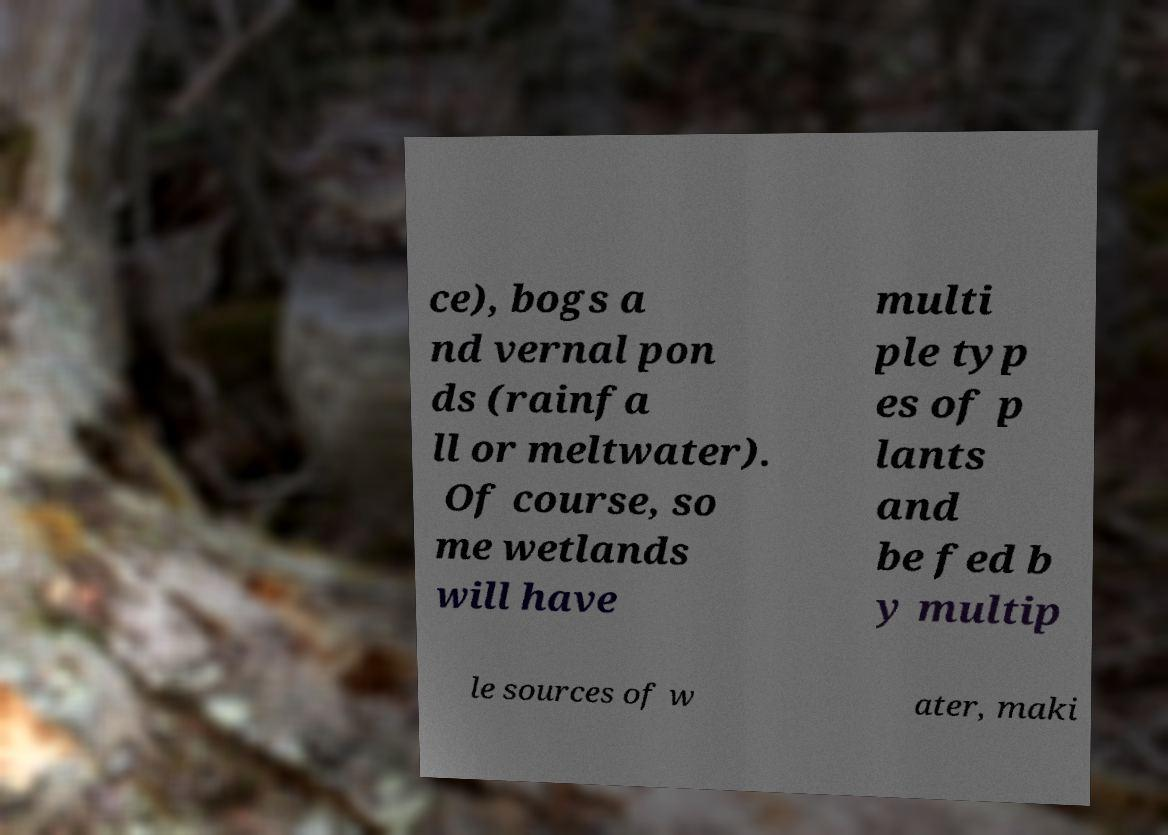Please identify and transcribe the text found in this image. ce), bogs a nd vernal pon ds (rainfa ll or meltwater). Of course, so me wetlands will have multi ple typ es of p lants and be fed b y multip le sources of w ater, maki 